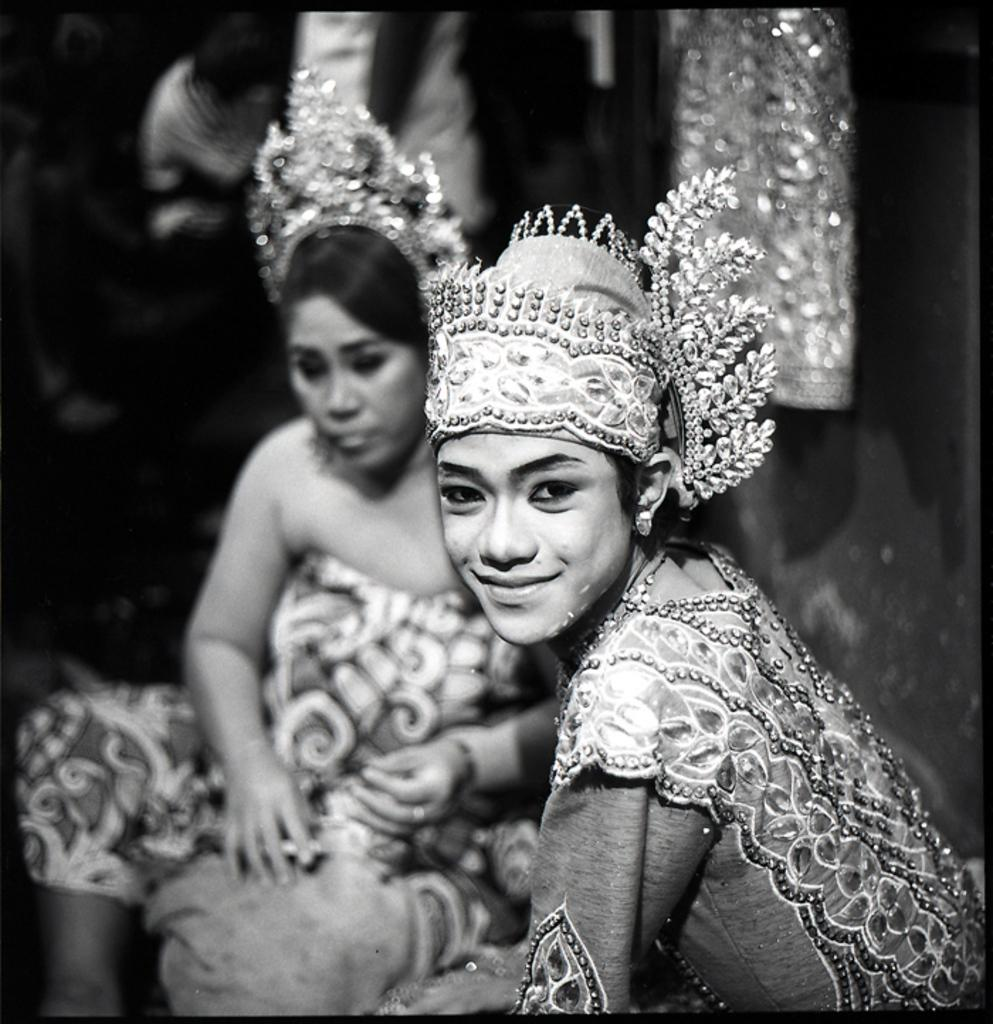What is the color scheme of the image? The image is black and white. Who can be seen in the image? There is a man and a woman in the image. How many attempts did the man make to divide the leg in the image? There is no leg or division present in the image; it features a man and a woman. 